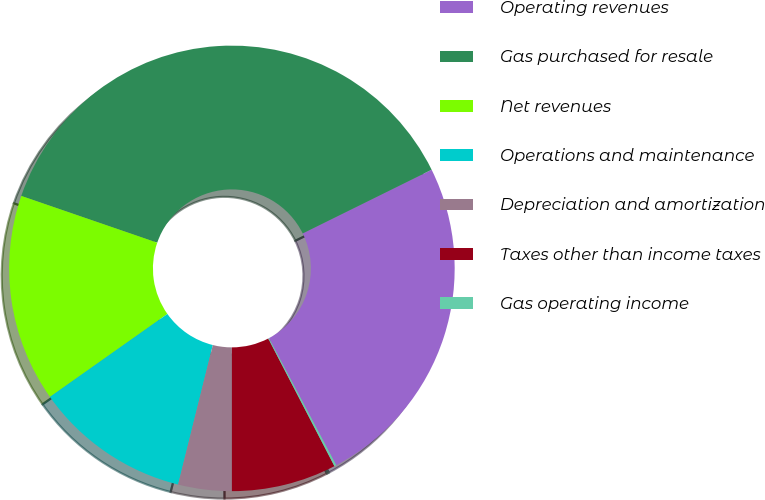Convert chart to OTSL. <chart><loc_0><loc_0><loc_500><loc_500><pie_chart><fcel>Operating revenues<fcel>Gas purchased for resale<fcel>Net revenues<fcel>Operations and maintenance<fcel>Depreciation and amortization<fcel>Taxes other than income taxes<fcel>Gas operating income<nl><fcel>24.54%<fcel>37.42%<fcel>15.06%<fcel>11.33%<fcel>3.88%<fcel>7.61%<fcel>0.15%<nl></chart> 